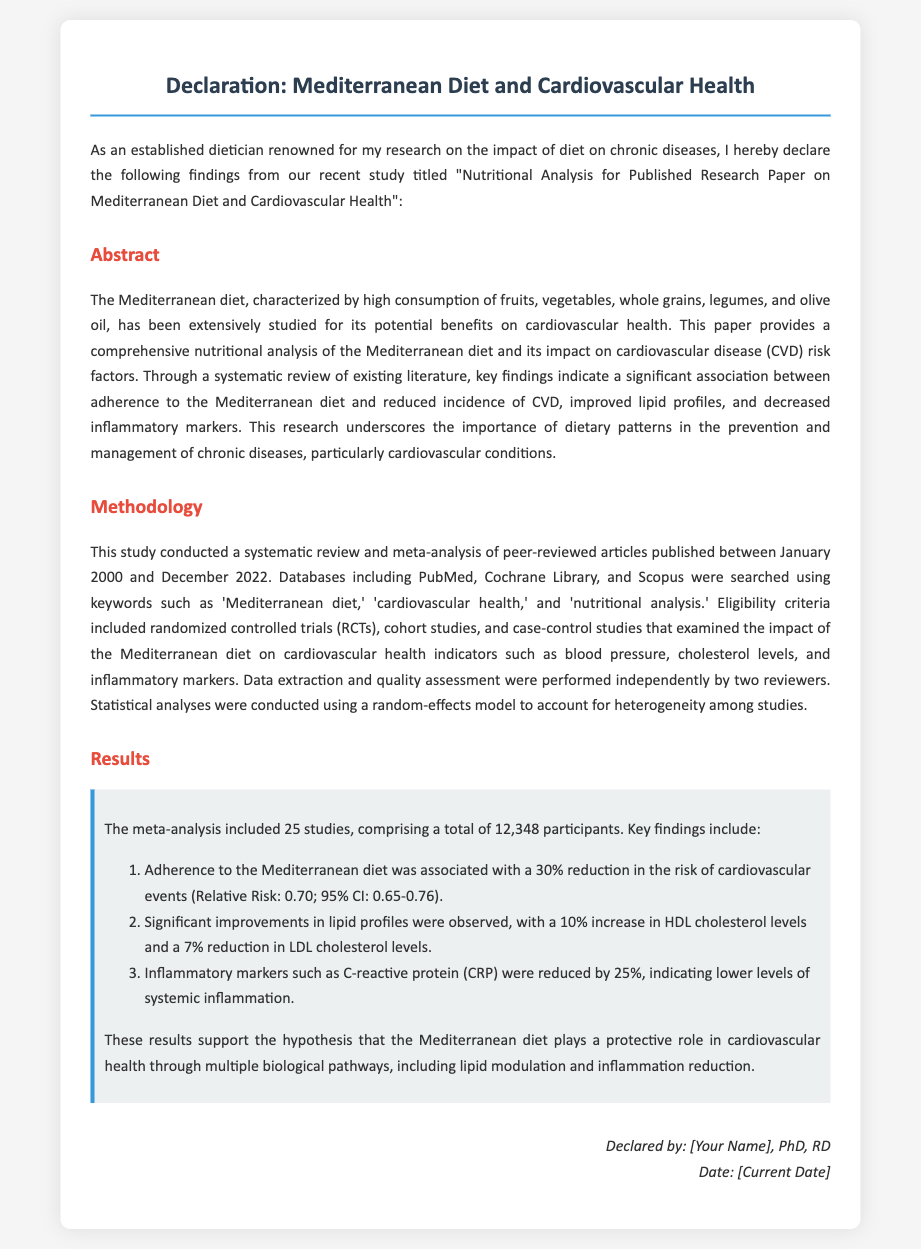What is the title of the study? The title of the study is stated in the declaration section, providing the focus of the research on diet and health.
Answer: Nutritional Analysis for Published Research Paper on Mediterranean Diet and Cardiovascular Health What date range was the literature reviewed in the methodology? The methodology mentions that the review included articles published between January 2000 and December 2022, indicating the timeframe of the research.
Answer: January 2000 to December 2022 How many studies were included in the meta-analysis? The results section specifies the number of studies considered in the analysis, reflecting the extent of the research conducted.
Answer: 25 studies By what percentage did adherence to the Mediterranean diet reduce the risk of cardiovascular events? The results section quantifies the impact of diet adherence on cardiovascular events, providing a clear statistical outcome.
Answer: 30% What were the participants' total number in the included studies? The document provides specific information about the collective number of participants in the reviewed studies.
Answer: 12,348 participants What statistical model was used for the analyses? The methodology indicates the type of statistical model employed to analyze the data, underlining the approaches taken in the research.
Answer: Random-effects model What marker was reduced by 25% according to the results? The results detail specific inflammatory markers affected by the Mediterranean diet, informing the impact of dietary patterns on health.
Answer: C-reactive protein (CRP) What institution conducted the research? The signature section typically provides the name and qualifications of the researcher, which may imply the institution's affiliation though not explicitly stated.
Answer: [Your Name] (as the researcher) 